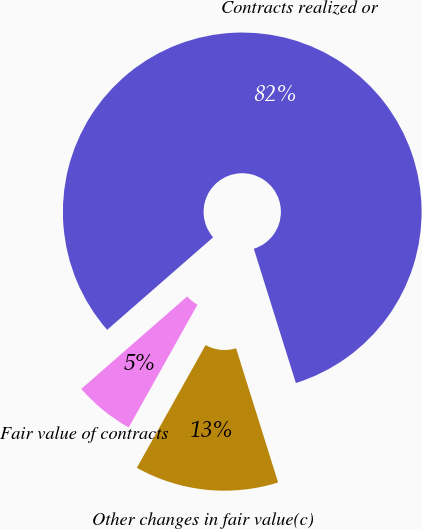Convert chart to OTSL. <chart><loc_0><loc_0><loc_500><loc_500><pie_chart><fcel>Fair value of contracts<fcel>Contracts realized or<fcel>Other changes in fair value(c)<nl><fcel>5.45%<fcel>81.59%<fcel>12.96%<nl></chart> 